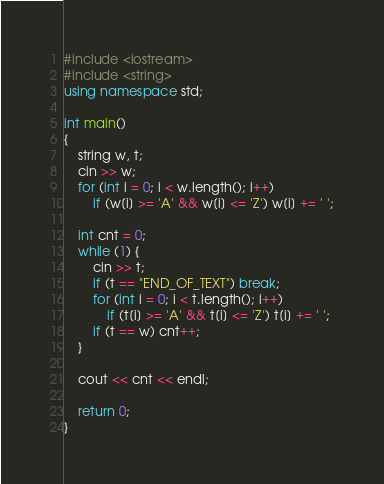<code> <loc_0><loc_0><loc_500><loc_500><_C++_>#include <iostream>
#include <string>
using namespace std;

int main()
{
    string w, t;
    cin >> w;
    for (int i = 0; i < w.length(); i++)
        if (w[i] >= 'A' && w[i] <= 'Z') w[i] += ' ';

    int cnt = 0;
    while (1) {
        cin >> t;
        if (t == "END_OF_TEXT") break;
        for (int i = 0; i < t.length(); i++)
            if (t[i] >= 'A' && t[i] <= 'Z') t[i] += ' ';
        if (t == w) cnt++;
    }

    cout << cnt << endl;

    return 0;
}</code> 